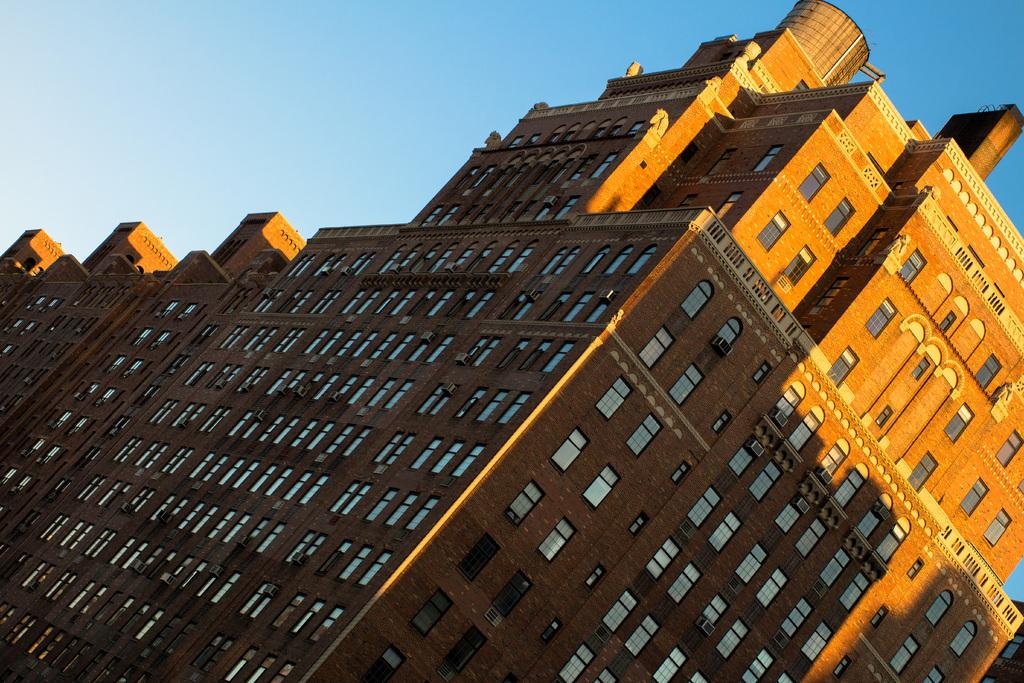What type of structures can be seen in the image? There are buildings in the image. What part of the natural environment is visible in the image? The sky is visible in the image. What type of material is used for the windows in the image? Glass windows are present in the image. What type of cooling system is visible in the image? Air conditioners are visible in the image. What type of plate is used to serve the food in the image? There is no food or plate present in the image; it features buildings, the sky, glass windows, and air conditioners. 